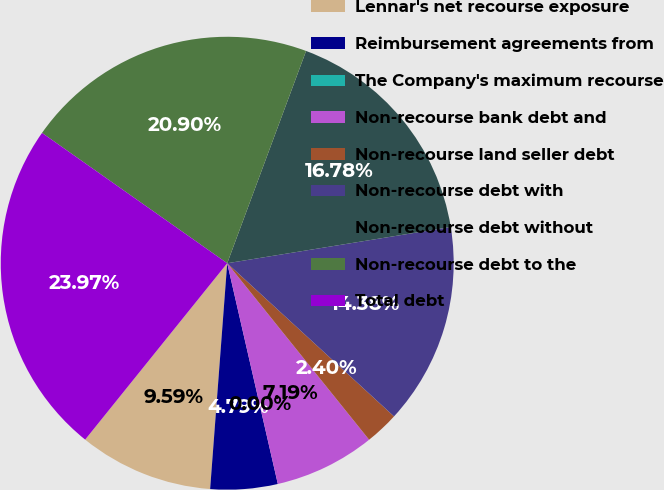Convert chart to OTSL. <chart><loc_0><loc_0><loc_500><loc_500><pie_chart><fcel>Lennar's net recourse exposure<fcel>Reimbursement agreements from<fcel>The Company's maximum recourse<fcel>Non-recourse bank debt and<fcel>Non-recourse land seller debt<fcel>Non-recourse debt with<fcel>Non-recourse debt without<fcel>Non-recourse debt to the<fcel>Total debt<nl><fcel>9.59%<fcel>4.79%<fcel>0.0%<fcel>7.19%<fcel>2.4%<fcel>14.38%<fcel>16.78%<fcel>20.9%<fcel>23.97%<nl></chart> 